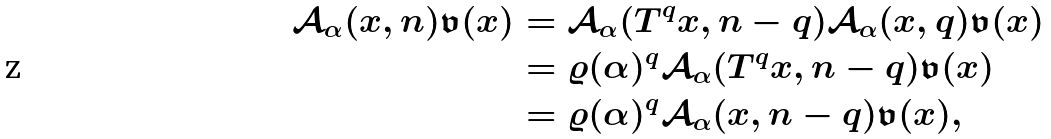<formula> <loc_0><loc_0><loc_500><loc_500>\mathcal { A } _ { \alpha } ( x , n ) \mathfrak { v } ( x ) & = \mathcal { A } _ { \alpha } ( T ^ { q } x , n - q ) \mathcal { A } _ { \alpha } ( x , q ) \mathfrak { v } ( x ) \\ & = \varrho ( \alpha ) ^ { q } \mathcal { A } _ { \alpha } ( T ^ { q } x , n - q ) \mathfrak { v } ( x ) \\ & = \varrho ( \alpha ) ^ { q } \mathcal { A } _ { \alpha } ( x , n - q ) \mathfrak { v } ( x ) ,</formula> 